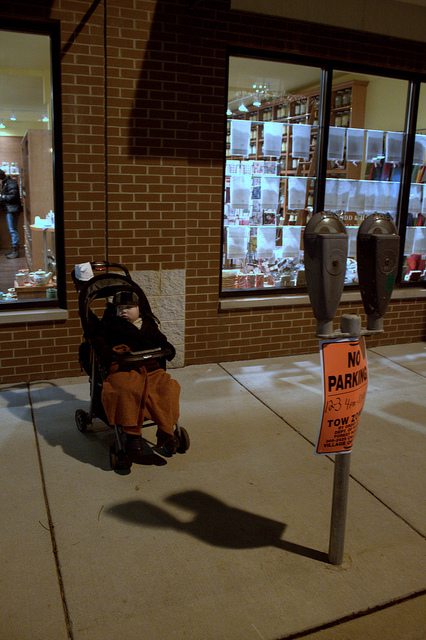<image>Is he playing a wifi game? I don't know if he is playing a wifi game. Is he playing a wifi game? He is not playing a wifi game. 